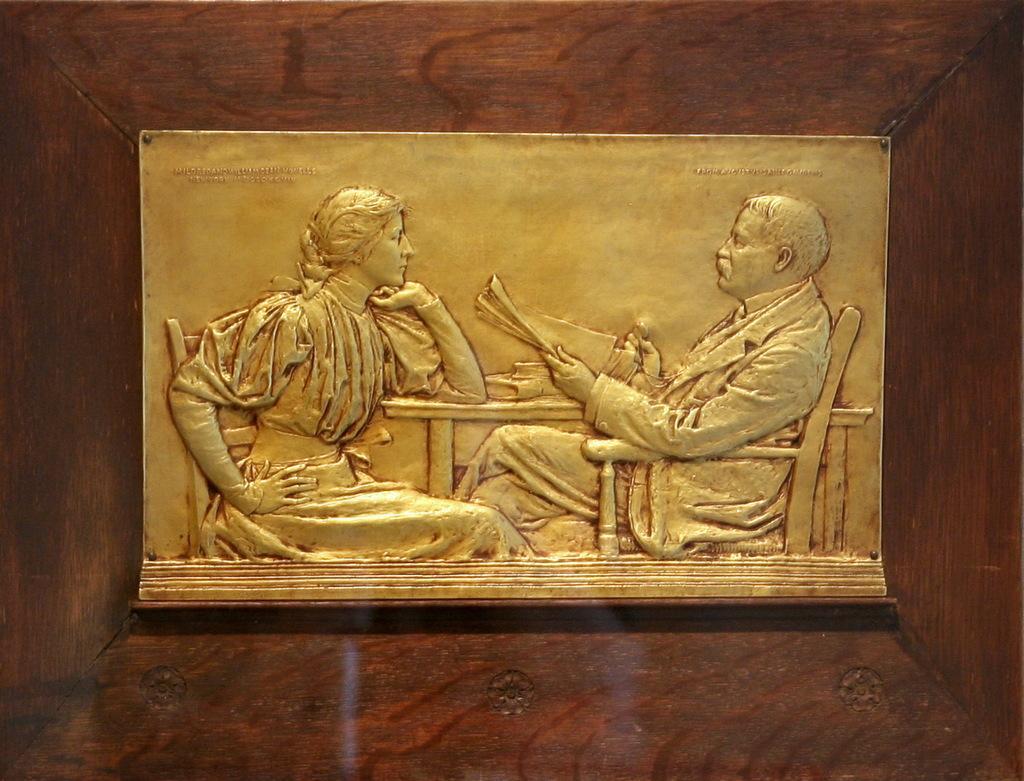Can you describe this image briefly? In the image there is a carving of man and woman sitting in chairs in front of table on a metal plate on the wall. 